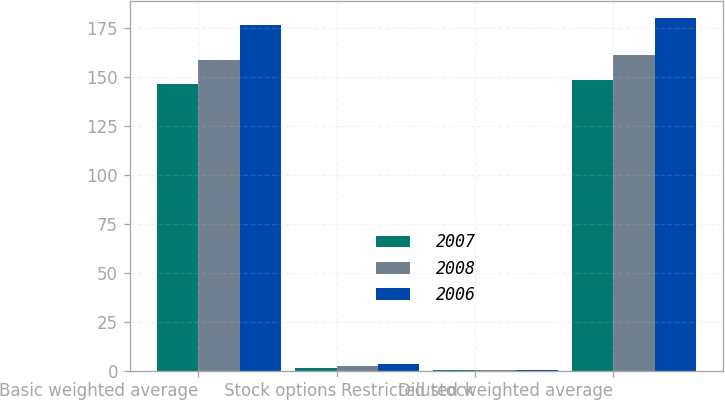Convert chart to OTSL. <chart><loc_0><loc_0><loc_500><loc_500><stacked_bar_chart><ecel><fcel>Basic weighted average<fcel>Stock options<fcel>Restricted stock<fcel>Diluted weighted average<nl><fcel>2007<fcel>146.5<fcel>1.6<fcel>0.1<fcel>148.2<nl><fcel>2008<fcel>158.7<fcel>2.4<fcel>0.1<fcel>161.2<nl><fcel>2006<fcel>176.6<fcel>3.2<fcel>0.1<fcel>179.9<nl></chart> 